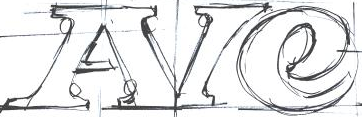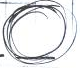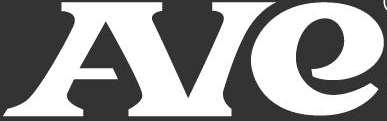Identify the words shown in these images in order, separated by a semicolon. AIe; .; AIe 